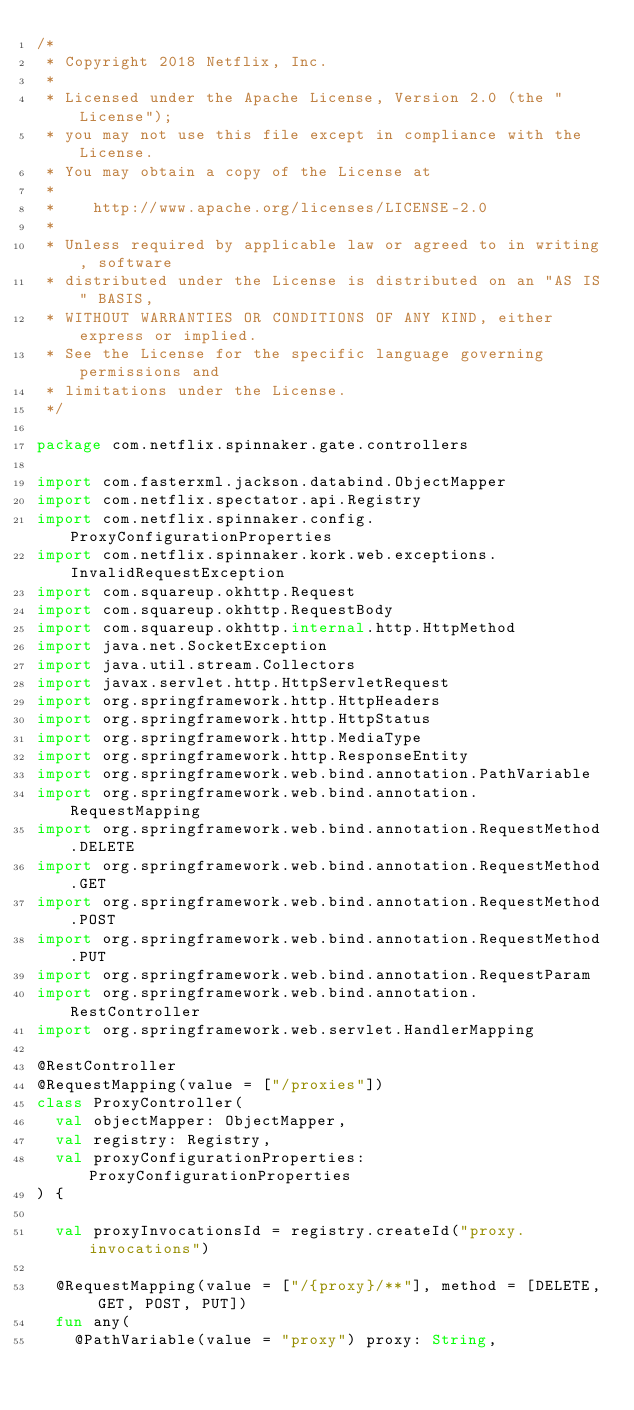<code> <loc_0><loc_0><loc_500><loc_500><_Kotlin_>/*
 * Copyright 2018 Netflix, Inc.
 *
 * Licensed under the Apache License, Version 2.0 (the "License");
 * you may not use this file except in compliance with the License.
 * You may obtain a copy of the License at
 *
 *    http://www.apache.org/licenses/LICENSE-2.0
 *
 * Unless required by applicable law or agreed to in writing, software
 * distributed under the License is distributed on an "AS IS" BASIS,
 * WITHOUT WARRANTIES OR CONDITIONS OF ANY KIND, either express or implied.
 * See the License for the specific language governing permissions and
 * limitations under the License.
 */

package com.netflix.spinnaker.gate.controllers

import com.fasterxml.jackson.databind.ObjectMapper
import com.netflix.spectator.api.Registry
import com.netflix.spinnaker.config.ProxyConfigurationProperties
import com.netflix.spinnaker.kork.web.exceptions.InvalidRequestException
import com.squareup.okhttp.Request
import com.squareup.okhttp.RequestBody
import com.squareup.okhttp.internal.http.HttpMethod
import java.net.SocketException
import java.util.stream.Collectors
import javax.servlet.http.HttpServletRequest
import org.springframework.http.HttpHeaders
import org.springframework.http.HttpStatus
import org.springframework.http.MediaType
import org.springframework.http.ResponseEntity
import org.springframework.web.bind.annotation.PathVariable
import org.springframework.web.bind.annotation.RequestMapping
import org.springframework.web.bind.annotation.RequestMethod.DELETE
import org.springframework.web.bind.annotation.RequestMethod.GET
import org.springframework.web.bind.annotation.RequestMethod.POST
import org.springframework.web.bind.annotation.RequestMethod.PUT
import org.springframework.web.bind.annotation.RequestParam
import org.springframework.web.bind.annotation.RestController
import org.springframework.web.servlet.HandlerMapping

@RestController
@RequestMapping(value = ["/proxies"])
class ProxyController(
  val objectMapper: ObjectMapper,
  val registry: Registry,
  val proxyConfigurationProperties: ProxyConfigurationProperties
) {

  val proxyInvocationsId = registry.createId("proxy.invocations")

  @RequestMapping(value = ["/{proxy}/**"], method = [DELETE, GET, POST, PUT])
  fun any(
    @PathVariable(value = "proxy") proxy: String,</code> 